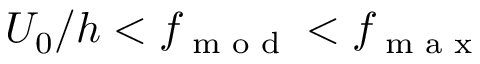Convert formula to latex. <formula><loc_0><loc_0><loc_500><loc_500>U _ { 0 } / h < f _ { m o d } < f _ { \max }</formula> 